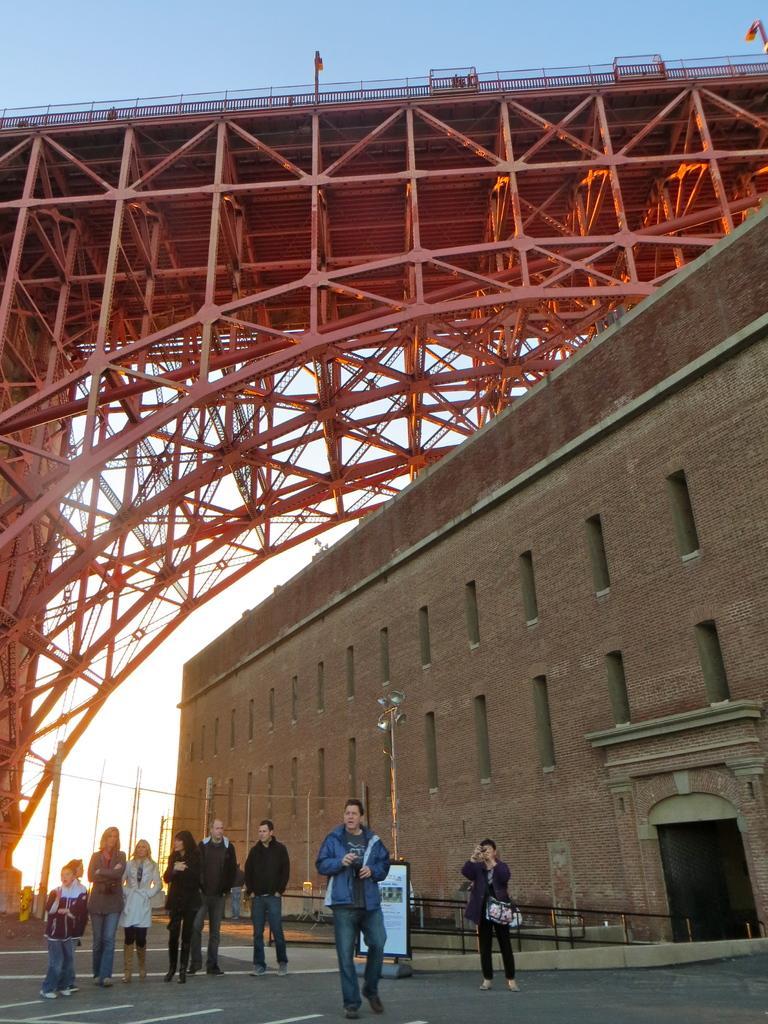Could you give a brief overview of what you see in this image? In this image in the middle there are persons standing and there is a person walking in the foreground. In the background there are buildings and there are towers and on the top there is a bridge. In front of the building there is a railing. 